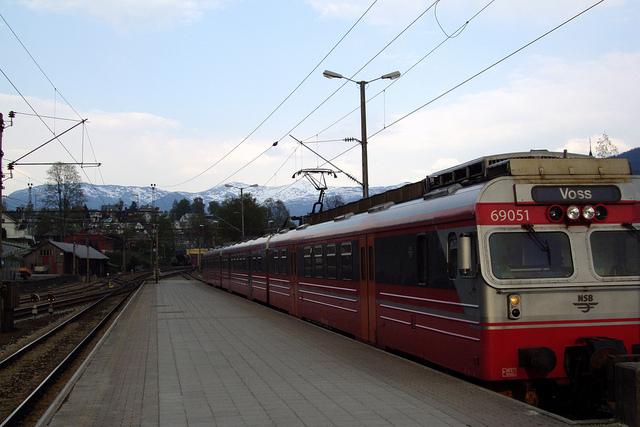What number is the train?
Short answer required. 69051. Is this a subway train?
Short answer required. No. Is this a passenger train?
Quick response, please. Yes. Was this photo taken from indoors looking outside?
Quick response, please. No. Do you see snow up in the mountain?
Give a very brief answer. Yes. 